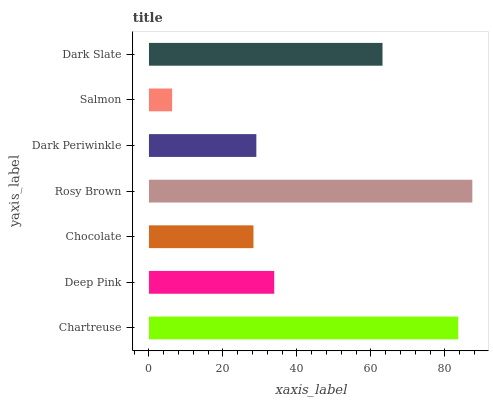Is Salmon the minimum?
Answer yes or no. Yes. Is Rosy Brown the maximum?
Answer yes or no. Yes. Is Deep Pink the minimum?
Answer yes or no. No. Is Deep Pink the maximum?
Answer yes or no. No. Is Chartreuse greater than Deep Pink?
Answer yes or no. Yes. Is Deep Pink less than Chartreuse?
Answer yes or no. Yes. Is Deep Pink greater than Chartreuse?
Answer yes or no. No. Is Chartreuse less than Deep Pink?
Answer yes or no. No. Is Deep Pink the high median?
Answer yes or no. Yes. Is Deep Pink the low median?
Answer yes or no. Yes. Is Chocolate the high median?
Answer yes or no. No. Is Chartreuse the low median?
Answer yes or no. No. 